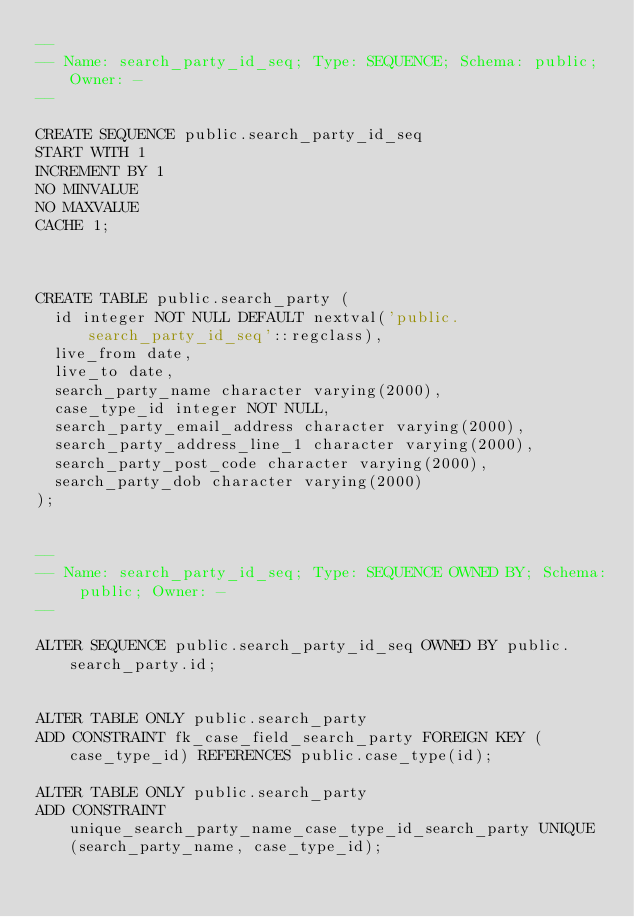<code> <loc_0><loc_0><loc_500><loc_500><_SQL_>--
-- Name: search_party_id_seq; Type: SEQUENCE; Schema: public; Owner: -
--

CREATE SEQUENCE public.search_party_id_seq
START WITH 1
INCREMENT BY 1
NO MINVALUE
NO MAXVALUE
CACHE 1;



CREATE TABLE public.search_party (
  id integer NOT NULL DEFAULT nextval('public.search_party_id_seq'::regclass),
  live_from date,
  live_to date,
  search_party_name character varying(2000),
  case_type_id integer NOT NULL,
  search_party_email_address character varying(2000),
  search_party_address_line_1 character varying(2000),
  search_party_post_code character varying(2000),
  search_party_dob character varying(2000)
);


--
-- Name: search_party_id_seq; Type: SEQUENCE OWNED BY; Schema: public; Owner: -
--

ALTER SEQUENCE public.search_party_id_seq OWNED BY public.search_party.id;


ALTER TABLE ONLY public.search_party
ADD CONSTRAINT fk_case_field_search_party FOREIGN KEY (case_type_id) REFERENCES public.case_type(id);

ALTER TABLE ONLY public.search_party
ADD CONSTRAINT unique_search_party_name_case_type_id_search_party UNIQUE (search_party_name, case_type_id);
</code> 